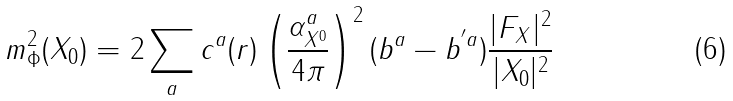<formula> <loc_0><loc_0><loc_500><loc_500>m _ { \Phi } ^ { 2 } ( X _ { 0 } ) = 2 \sum _ { a } c ^ { a } ( r ) \left ( \frac { \alpha _ { X ^ { 0 } } ^ { a } } { 4 \pi } \right ) ^ { 2 } ( b ^ { a } - b ^ { ^ { \prime } a } ) \frac { | F _ { X } | ^ { 2 } } { | X _ { 0 } | ^ { 2 } }</formula> 